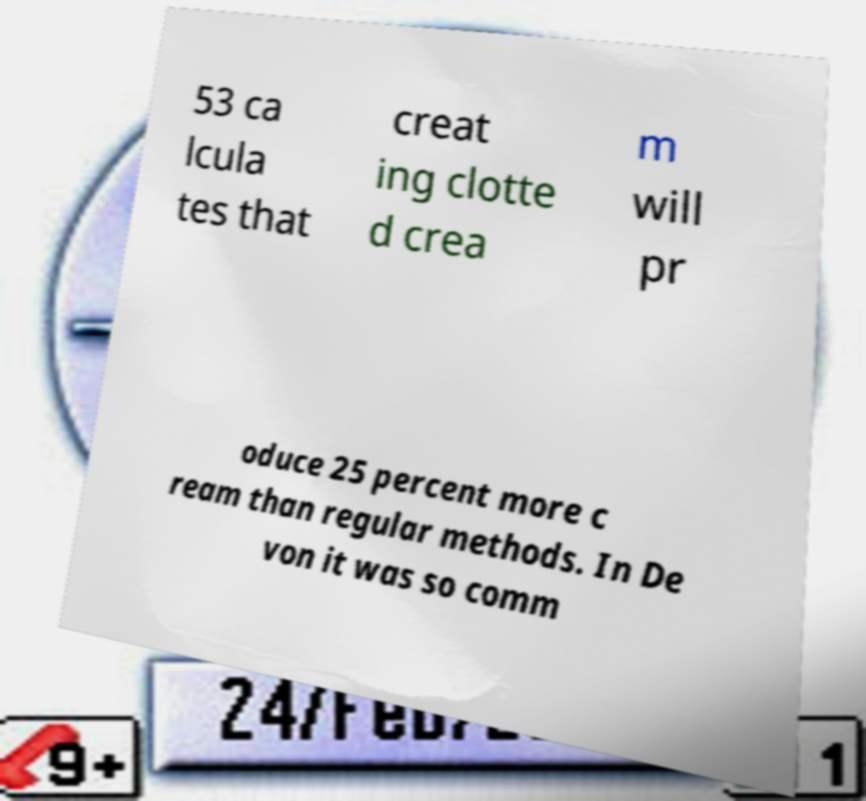Please identify and transcribe the text found in this image. 53 ca lcula tes that creat ing clotte d crea m will pr oduce 25 percent more c ream than regular methods. In De von it was so comm 